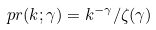Convert formula to latex. <formula><loc_0><loc_0><loc_500><loc_500>\ p r ( k ; \gamma ) = k ^ { - \gamma } / \zeta ( \gamma )</formula> 